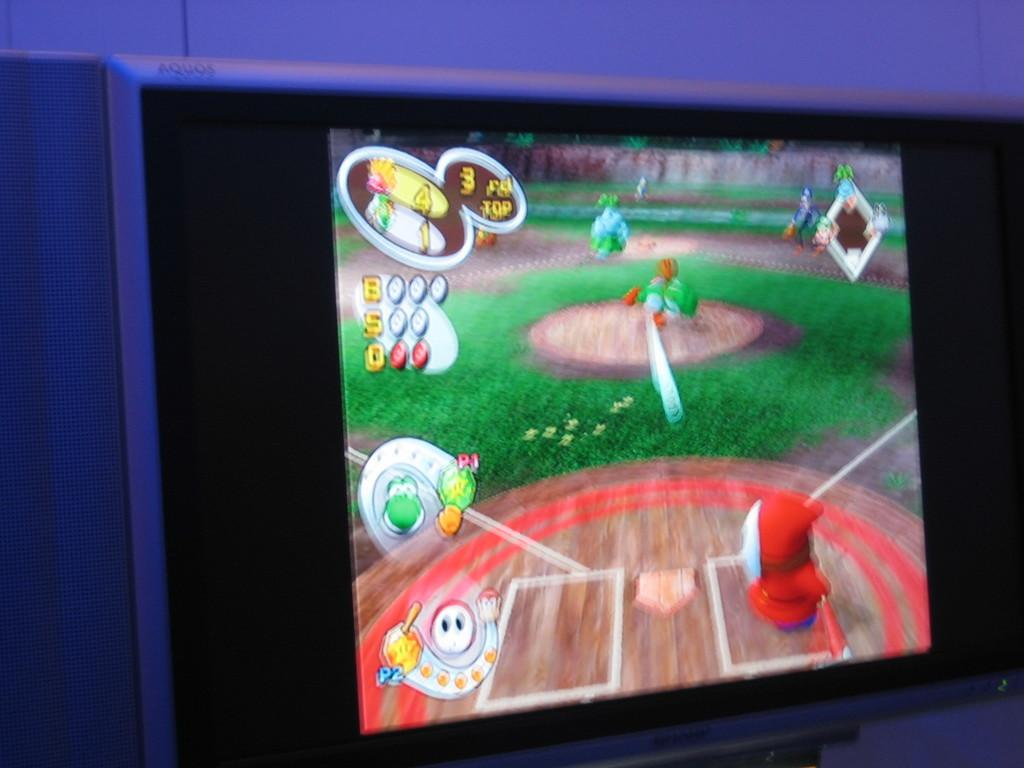<image>
Share a concise interpretation of the image provided. A children's video game shows numbers 1 4 and 3 in the left corner. 